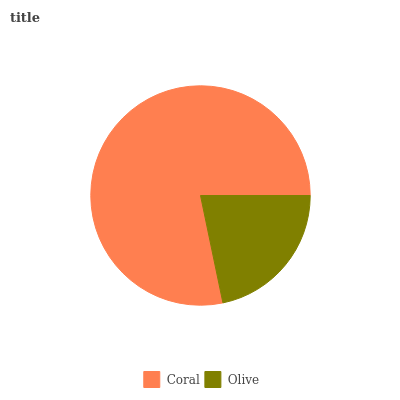Is Olive the minimum?
Answer yes or no. Yes. Is Coral the maximum?
Answer yes or no. Yes. Is Olive the maximum?
Answer yes or no. No. Is Coral greater than Olive?
Answer yes or no. Yes. Is Olive less than Coral?
Answer yes or no. Yes. Is Olive greater than Coral?
Answer yes or no. No. Is Coral less than Olive?
Answer yes or no. No. Is Coral the high median?
Answer yes or no. Yes. Is Olive the low median?
Answer yes or no. Yes. Is Olive the high median?
Answer yes or no. No. Is Coral the low median?
Answer yes or no. No. 